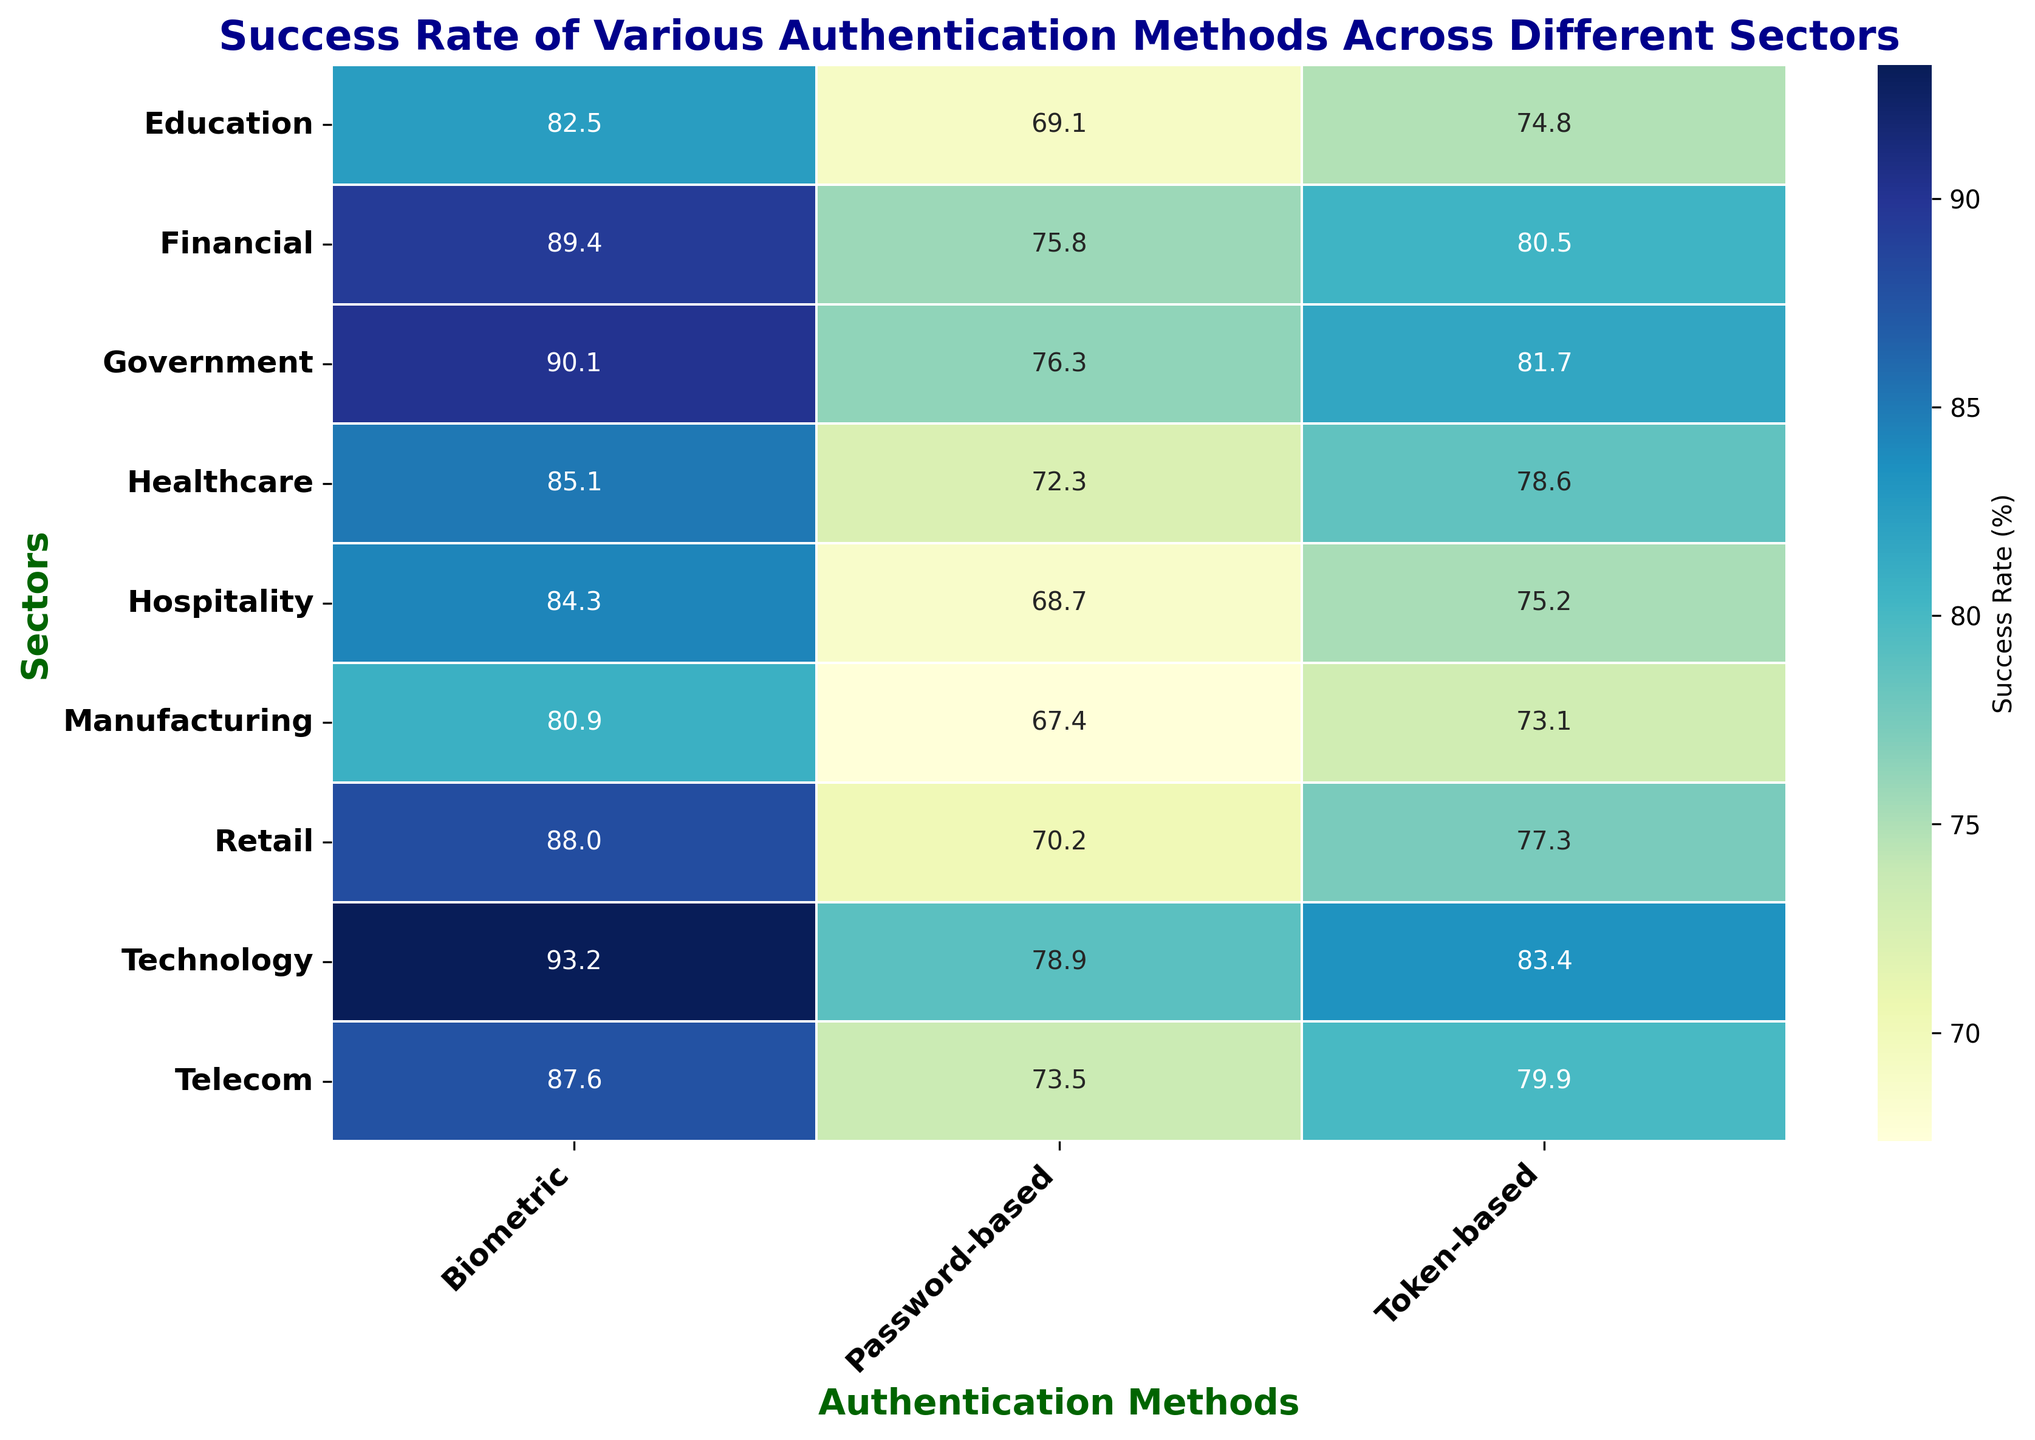What's the best authentication method for the Technology sector? The heatmap shows the success rates of different authentication methods across sectors. For the Technology sector, the success rates are 93.2% for Biometric, 78.9% for Password-based, and 83.4% for Token-based. Biometric has the highest success rate.
Answer: Biometric Which sector has the lowest success rate for Password-based authentication? By examining the vertical column for Password-based authentication, the sector 'Manufacturing' has the lowest success rate at 67.4%.
Answer: Manufacturing What is the average success rate of Biometric authentication across all sectors? Sum the success rates for Biometric authentication in all sectors and divide by the number of sectors: (89.4 + 85.1 + 88.0 + 82.5 + 90.1 + 93.2 + 87.6 + 84.3 + 80.9) / 9 = 88.0%.
Answer: 88.0% Which authentication method has the most variation in success rates across sectors? Observe the range of success rates for each method. Biometric ranges from 80.9% to 93.2%, Password-based from 67.4% to 78.9%, and Token-based from 73.1% to 83.4%. Password-based shows the most variation.
Answer: Password-based Compare the success rate of Token-based authentication in the Financial and Government sectors. The success rate for Token-based in Financial is 80.5%, and in Government, it is 81.7%. Government has a slightly higher success rate.
Answer: Government Which sector has the most balanced success rates across all authentication methods? Look for a sector where the success rates are close to each other. The Financial sector has rates of 89.4%, 75.8%, and 80.5%, while Healthcare has rates of 85.1%, 72.3%, and 78.6%. Healthcare seems more balanced.
Answer: Healthcare What is the success rate difference between Biometric and Password-based authentication in the Education sector? The success rate for Biometric in Education is 82.5%, and for Password-based, it is 69.1%. The difference is 82.5% - 69.1% = 13.4%.
Answer: 13.4% Which sector has the highest success rate for Token-based authentication, and what is that rate? The heatmap shows that the Technology sector has the highest success rate for Token-based authentication at 83.4%.
Answer: Technology; 83.4% What is the median success rate for Password-based authentication across all sectors? Arrange the success rates in ascending order: 67.4, 68.7, 69.1, 70.2, 72.3, 73.5, 75.8, 76.3, 78.9. The middle value (median) is 72.3%.
Answer: 72.3% Compare the overall performance (average success rate) of Biometric and Password-based authentication methods. Calculate the average success rates: Biometric - (89.4 + 85.1 + 88.0 + 82.5 + 90.1 + 93.2 + 87.6 + 84.3 + 80.9) / 9 = 88.0%. Password-based - (75.8 + 72.3 + 70.2 + 69.1 + 76.3 + 78.9 + 73.5 + 68.7 + 67.4) / 9 = 72.5%. Biometric has a higher average success rate.
Answer: Biometric; 88.0% 